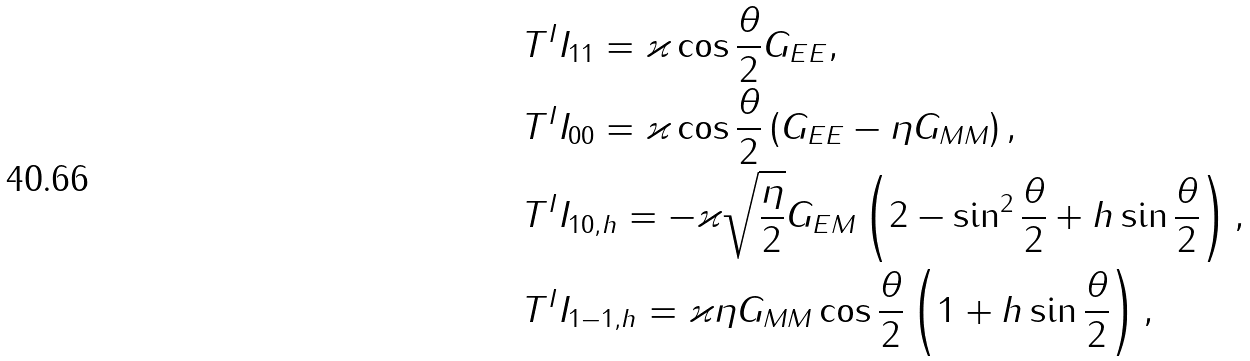Convert formula to latex. <formula><loc_0><loc_0><loc_500><loc_500>& T ^ { I } I _ { 1 1 } = \varkappa \cos \frac { \theta } 2 G _ { E E } , \\ & T ^ { I } I _ { 0 0 } = \varkappa \cos \frac { \theta } 2 \left ( G _ { E E } - \eta G _ { M M } \right ) , \\ & T ^ { I } I _ { 1 0 , h } = - \varkappa \sqrt { \frac { \eta } { 2 } } G _ { E M } \left ( 2 - \sin ^ { 2 } \frac { \theta } 2 + h \sin \frac { \theta } 2 \right ) , \\ & T ^ { I } I _ { 1 - 1 , h } = \varkappa \eta G _ { M M } \cos \frac { \theta } 2 \left ( 1 + h \sin \frac { \theta } 2 \right ) ,</formula> 